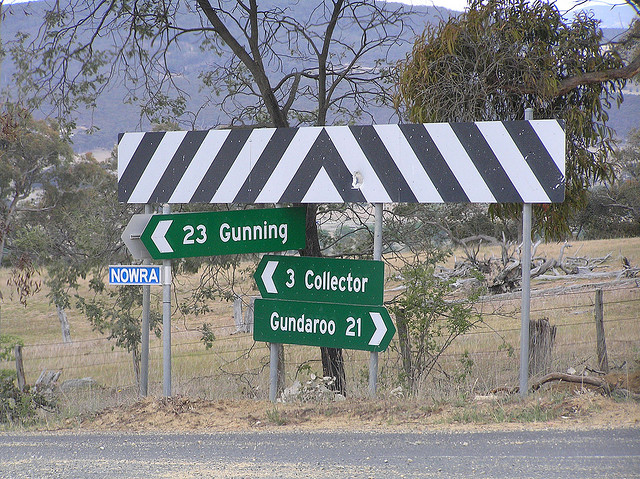Identify the text displayed in this image. 23 Gunning NOWRA 3 Collector 21 Gundaroo 